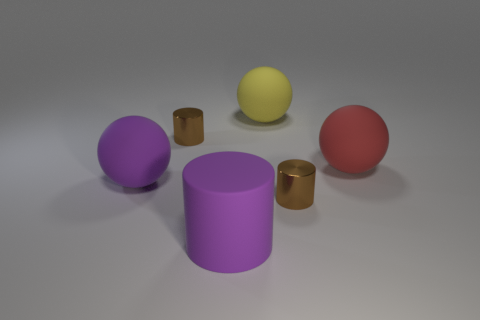Subtract all red matte spheres. How many spheres are left? 2 Subtract all cyan spheres. How many brown cylinders are left? 2 Subtract 1 cylinders. How many cylinders are left? 2 Add 1 purple rubber things. How many objects exist? 7 Subtract all cyan balls. Subtract all green blocks. How many balls are left? 3 Add 5 large purple matte objects. How many large purple matte objects exist? 7 Subtract 0 red blocks. How many objects are left? 6 Subtract all large purple rubber balls. Subtract all big purple matte spheres. How many objects are left? 4 Add 3 red balls. How many red balls are left? 4 